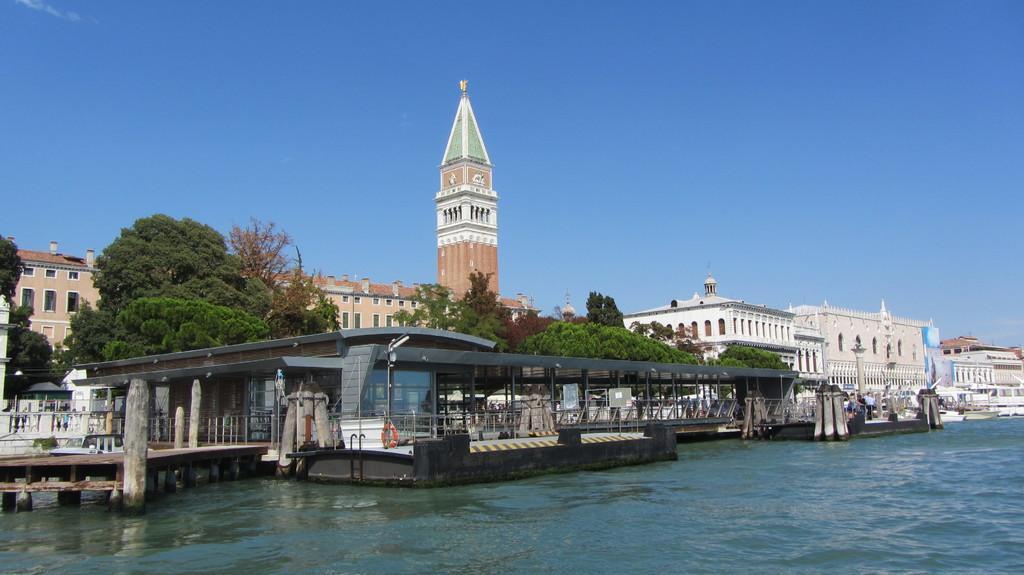How would you summarize this image in a sentence or two? In this image I can see the water and the wooden bridge. In the background I can see many trees, buildings and the sky. 